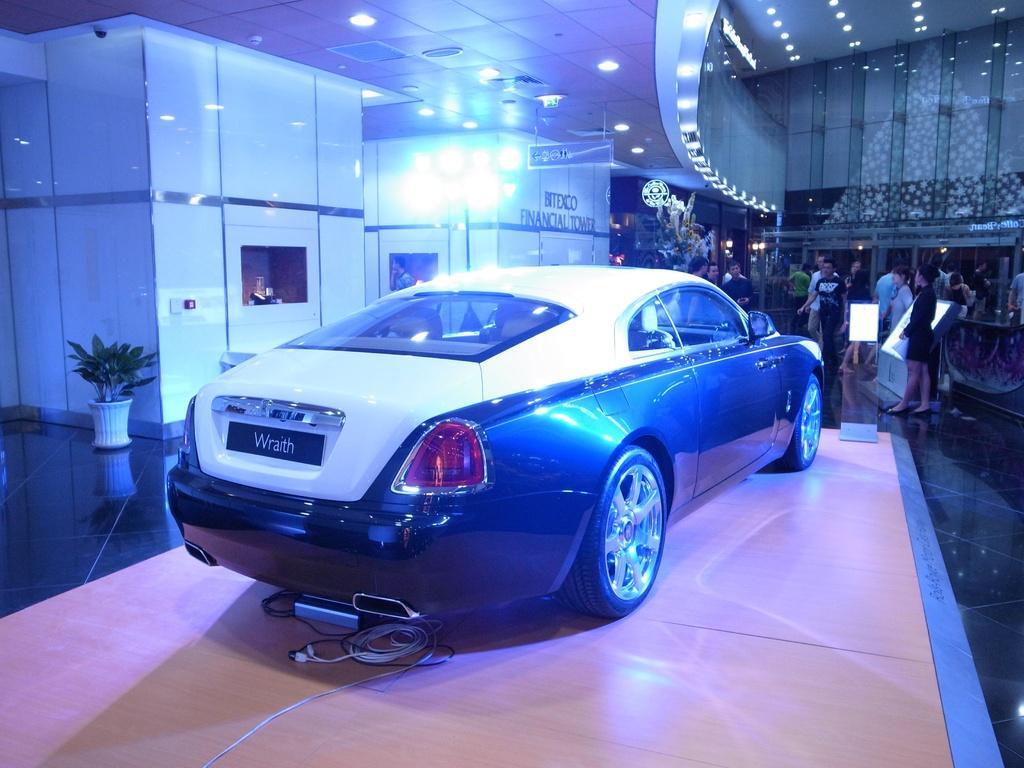How would you summarize this image in a sentence or two? In this picture we can see car and cables on the platform. There are people and we can see plant with pot, screen, glass box and objects. At the top we can see lights and board. We can see text on the wall. 